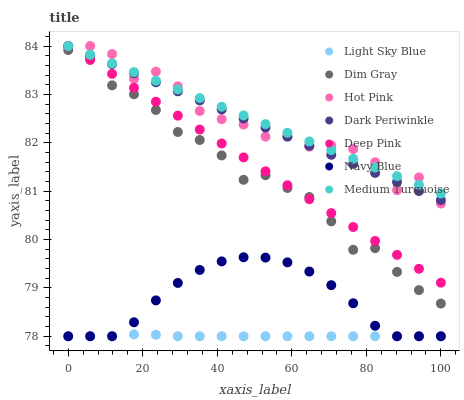Does Light Sky Blue have the minimum area under the curve?
Answer yes or no. Yes. Does Medium Turquoise have the maximum area under the curve?
Answer yes or no. Yes. Does Navy Blue have the minimum area under the curve?
Answer yes or no. No. Does Navy Blue have the maximum area under the curve?
Answer yes or no. No. Is Dark Periwinkle the smoothest?
Answer yes or no. Yes. Is Hot Pink the roughest?
Answer yes or no. Yes. Is Navy Blue the smoothest?
Answer yes or no. No. Is Navy Blue the roughest?
Answer yes or no. No. Does Navy Blue have the lowest value?
Answer yes or no. Yes. Does Hot Pink have the lowest value?
Answer yes or no. No. Does Dark Periwinkle have the highest value?
Answer yes or no. Yes. Does Navy Blue have the highest value?
Answer yes or no. No. Is Navy Blue less than Dim Gray?
Answer yes or no. Yes. Is Medium Turquoise greater than Dim Gray?
Answer yes or no. Yes. Does Medium Turquoise intersect Dark Periwinkle?
Answer yes or no. Yes. Is Medium Turquoise less than Dark Periwinkle?
Answer yes or no. No. Is Medium Turquoise greater than Dark Periwinkle?
Answer yes or no. No. Does Navy Blue intersect Dim Gray?
Answer yes or no. No. 